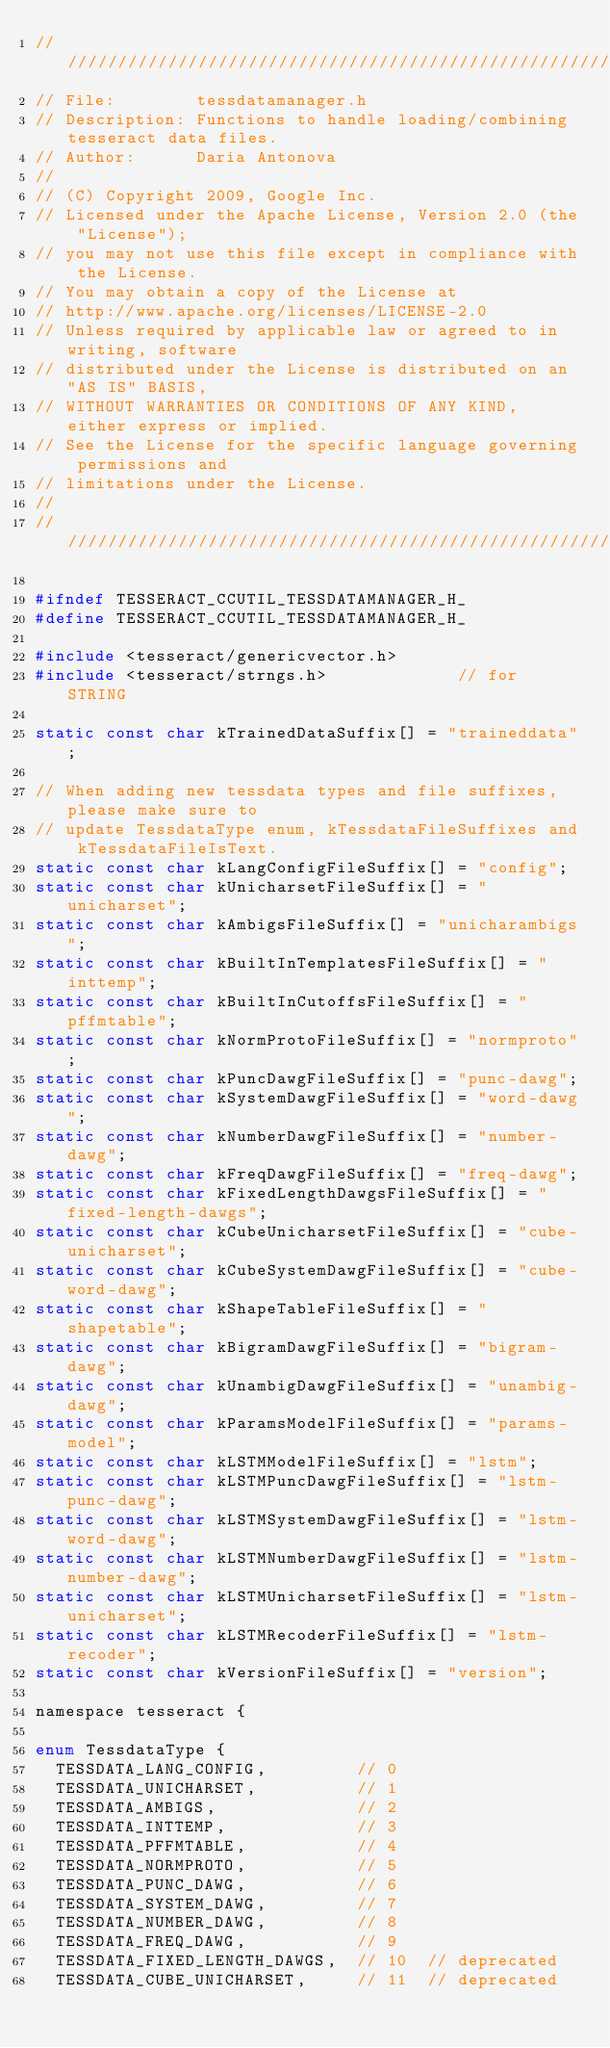<code> <loc_0><loc_0><loc_500><loc_500><_C_>///////////////////////////////////////////////////////////////////////
// File:        tessdatamanager.h
// Description: Functions to handle loading/combining tesseract data files.
// Author:      Daria Antonova
//
// (C) Copyright 2009, Google Inc.
// Licensed under the Apache License, Version 2.0 (the "License");
// you may not use this file except in compliance with the License.
// You may obtain a copy of the License at
// http://www.apache.org/licenses/LICENSE-2.0
// Unless required by applicable law or agreed to in writing, software
// distributed under the License is distributed on an "AS IS" BASIS,
// WITHOUT WARRANTIES OR CONDITIONS OF ANY KIND, either express or implied.
// See the License for the specific language governing permissions and
// limitations under the License.
//
///////////////////////////////////////////////////////////////////////

#ifndef TESSERACT_CCUTIL_TESSDATAMANAGER_H_
#define TESSERACT_CCUTIL_TESSDATAMANAGER_H_

#include <tesseract/genericvector.h>
#include <tesseract/strngs.h>             // for STRING

static const char kTrainedDataSuffix[] = "traineddata";

// When adding new tessdata types and file suffixes, please make sure to
// update TessdataType enum, kTessdataFileSuffixes and kTessdataFileIsText.
static const char kLangConfigFileSuffix[] = "config";
static const char kUnicharsetFileSuffix[] = "unicharset";
static const char kAmbigsFileSuffix[] = "unicharambigs";
static const char kBuiltInTemplatesFileSuffix[] = "inttemp";
static const char kBuiltInCutoffsFileSuffix[] = "pffmtable";
static const char kNormProtoFileSuffix[] = "normproto";
static const char kPuncDawgFileSuffix[] = "punc-dawg";
static const char kSystemDawgFileSuffix[] = "word-dawg";
static const char kNumberDawgFileSuffix[] = "number-dawg";
static const char kFreqDawgFileSuffix[] = "freq-dawg";
static const char kFixedLengthDawgsFileSuffix[] = "fixed-length-dawgs";
static const char kCubeUnicharsetFileSuffix[] = "cube-unicharset";
static const char kCubeSystemDawgFileSuffix[] = "cube-word-dawg";
static const char kShapeTableFileSuffix[] = "shapetable";
static const char kBigramDawgFileSuffix[] = "bigram-dawg";
static const char kUnambigDawgFileSuffix[] = "unambig-dawg";
static const char kParamsModelFileSuffix[] = "params-model";
static const char kLSTMModelFileSuffix[] = "lstm";
static const char kLSTMPuncDawgFileSuffix[] = "lstm-punc-dawg";
static const char kLSTMSystemDawgFileSuffix[] = "lstm-word-dawg";
static const char kLSTMNumberDawgFileSuffix[] = "lstm-number-dawg";
static const char kLSTMUnicharsetFileSuffix[] = "lstm-unicharset";
static const char kLSTMRecoderFileSuffix[] = "lstm-recoder";
static const char kVersionFileSuffix[] = "version";

namespace tesseract {

enum TessdataType {
  TESSDATA_LANG_CONFIG,         // 0
  TESSDATA_UNICHARSET,          // 1
  TESSDATA_AMBIGS,              // 2
  TESSDATA_INTTEMP,             // 3
  TESSDATA_PFFMTABLE,           // 4
  TESSDATA_NORMPROTO,           // 5
  TESSDATA_PUNC_DAWG,           // 6
  TESSDATA_SYSTEM_DAWG,         // 7
  TESSDATA_NUMBER_DAWG,         // 8
  TESSDATA_FREQ_DAWG,           // 9
  TESSDATA_FIXED_LENGTH_DAWGS,  // 10  // deprecated
  TESSDATA_CUBE_UNICHARSET,     // 11  // deprecated</code> 